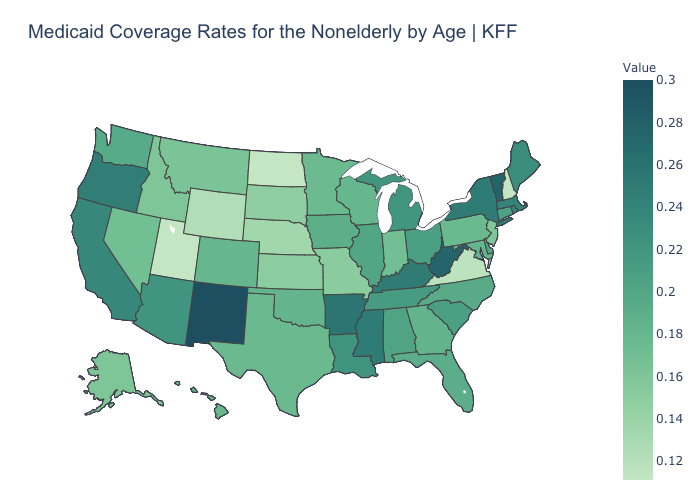Among the states that border Massachusetts , which have the highest value?
Short answer required. Vermont. Which states hav the highest value in the Northeast?
Quick response, please. Vermont. Does Colorado have the highest value in the West?
Quick response, please. No. Which states hav the highest value in the West?
Write a very short answer. New Mexico. Does the map have missing data?
Write a very short answer. No. Among the states that border Minnesota , does Iowa have the highest value?
Quick response, please. Yes. Does Kentucky have the highest value in the USA?
Concise answer only. No. Among the states that border Rhode Island , does Connecticut have the highest value?
Keep it brief. No. 